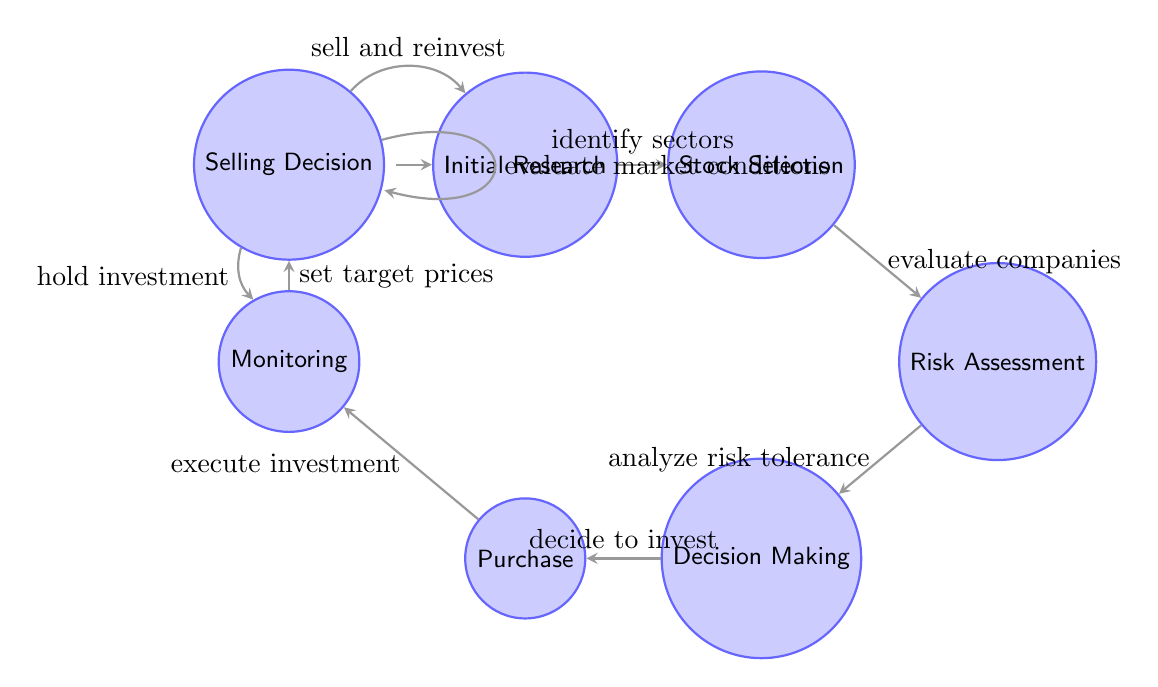What is the first state in the diagram? The first state is labeled "Initial Research," which is identified as the starting point of the process as indicated by its position in the diagram.
Answer: Initial Research How many states are in the diagram? By counting the individual labeled states in the diagram, we find there are a total of seven distinct states.
Answer: 7 What triggers the transition from Stock Selection to Risk Assessment? The transition from Stock Selection to Risk Assessment is triggered by the action labeled "evaluate companies," which is indicated on the connecting edge between these two states.
Answer: evaluate companies What is the final state in the Selling Decision loop? The final state in the loop for Selling Decision is "Selling Decision" itself, as the loop indicates that this state can reference itself through the "evaluate market conditions."
Answer: Selling Decision If a decision is made to sell, which state will it return to? If a decision to sell and reinvest is made, the process will return to "Initial Research," as indicated by the respective transition labeled "sell and reinvest."
Answer: Initial Research How many transitions lead out of the Monitoring state? There are two transitions that lead out of the Monitoring state: one going to Selling Decision and another going back to itself under the hold investment action.
Answer: 2 What is the action that triggers the move from Decision Making to Purchase? The action that triggers the transition from Decision Making to Purchase is labeled "decide to invest," as shown on the edge connecting these two states.
Answer: decide to invest What does the transition from Monitoring to Selling Decision represent? The transition from Monitoring to Selling Decision represents the action where "set target prices" is established, indicating readiness for possible selling actions based on market conditions.
Answer: set target prices What happens if the Selling Decision state evaluates market conditions? Evaluating market conditions results in remaining in the same state, as shown by the loop back to Selling Decision which signifies continuous market evaluation.
Answer: stays in Selling Decision 